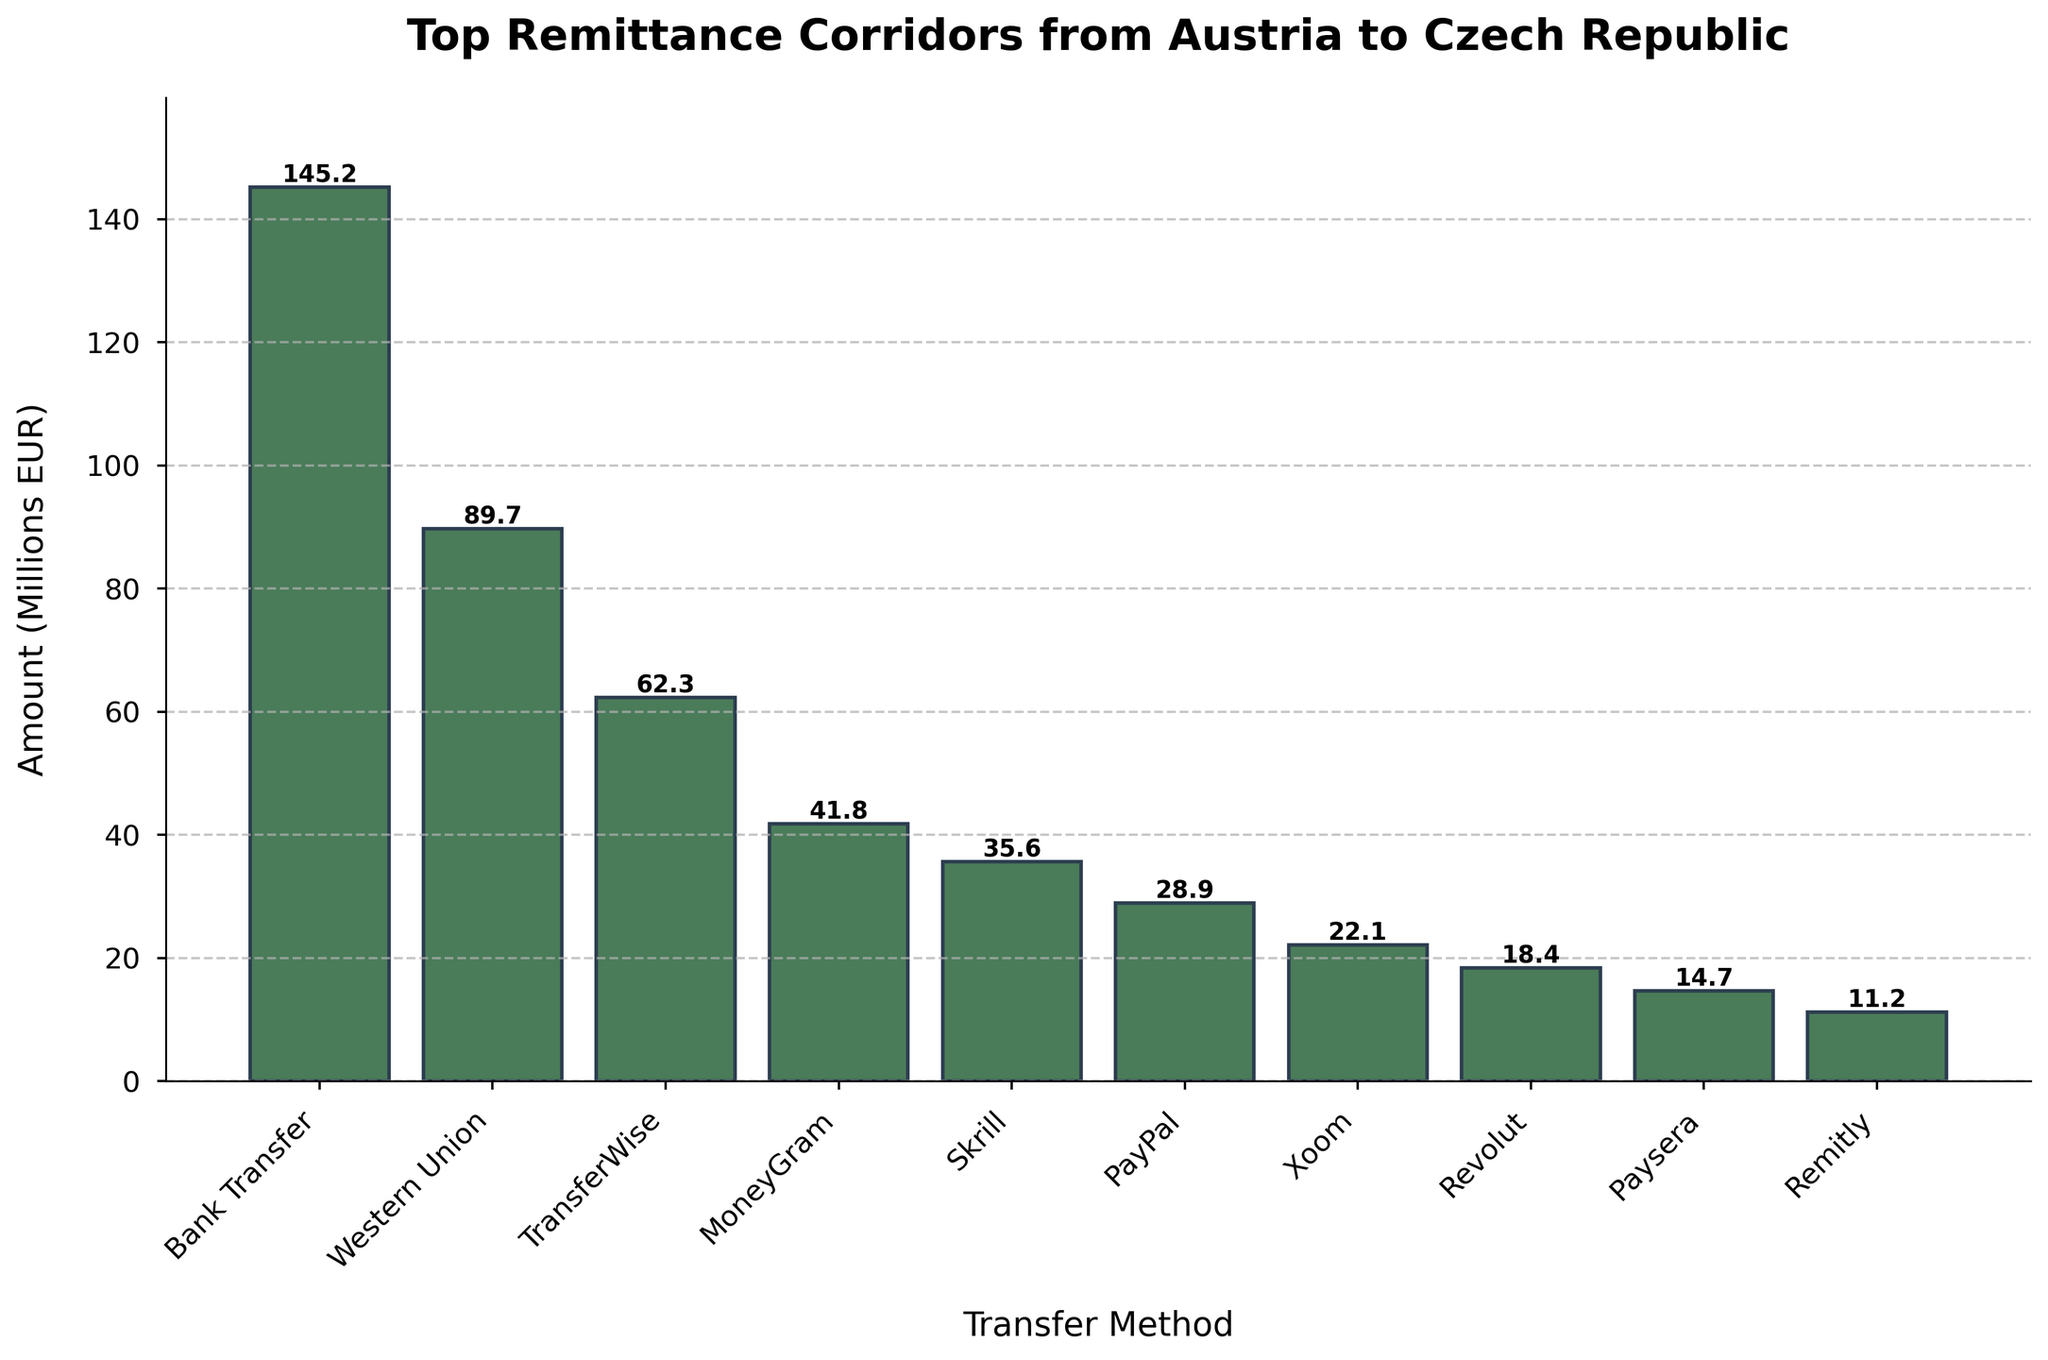Which transfer method has the highest amount sent? The highest bar in the chart represents the method with the highest amount sent. The bar for "Bank Transfer" is the tallest, indicating it has the highest amount.
Answer: Bank Transfer Which transfer method has the smallest amount sent? The shortest bar in the chart represents the method with the smallest amount sent. The bar for "Remitly" is the shortest, indicating it has the smallest amount.
Answer: Remitly What is the total amount sent by the top three transfer methods? The top three methods are those with the tallest bars. Sum the amounts for "Bank Transfer" (145.2), "Western Union" (89.7), and "TransferWise" (62.3). 145.2 + 89.7 + 62.3 = 297.2
Answer: 297.2 Which transfer methods have an amount higher than 50 million EUR? Identify the bars that extend beyond the 50-million EUR mark. These include "Bank Transfer", "Western Union", and "TransferWise".
Answer: Bank Transfer, Western Union, TransferWise How much less is sent via Skrill compared to MoneyGram? Find the bars for "Skrill" and "MoneyGram" and subtract the height of Skrill (35.6) from the height of MoneyGram (41.8). 41.8 - 35.6 = 6.2
Answer: 6.2 What is the average amount sent by PayPal, Xoom, Revolut, and Paysera? Sum the amounts for "PayPal" (28.9), "Xoom" (22.1), "Revolut" (18.4), and "Paysera" (14.7), then divide by the number of methods (4). (28.9 + 22.1 + 18.4 + 14.7) / 4 = 84.1 / 4 = 21.025
Answer: 21.025 Which transfer method is closest to the median amount sent? List the amounts and order them: 11.2, 14.7, 18.4, 22.1, 28.9, 35.6, 41.8, 62.3, 89.7, 145.2. The median value is the average of the 5th and 6th values (28.9 and 35.6). (28.9 + 35.6) / 2 = 32.25, so the closest is "PayPal" with 28.9.
Answer: PayPal What is the difference in amount sent between Western Union and TransferWise? Find the bar heights for "Western Union" and "TransferWise" and subtract the smaller from the larger. 89.7 - 62.3 = 27.4
Answer: 27.4 Which three transfer methods have amounts between 20 million EUR and 40 million EUR? Identify the bars whose heights fall between 20 and 40 million EUR. These include "MoneyGram" (41.8 is slightly above, skip it), "Skrill", "PayPal", and "Xoom".
Answer: Skrill, PayPal, Xoom 